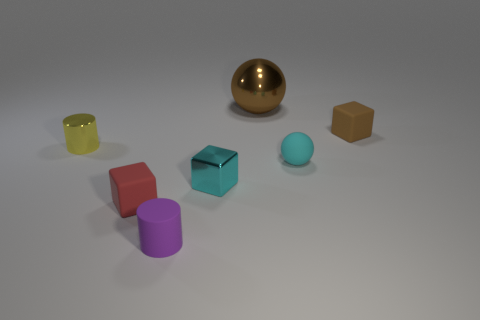Add 3 tiny metallic cubes. How many objects exist? 10 Subtract all balls. How many objects are left? 5 Subtract all small cyan matte objects. Subtract all small yellow cylinders. How many objects are left? 5 Add 6 small yellow metal cylinders. How many small yellow metal cylinders are left? 7 Add 3 matte cylinders. How many matte cylinders exist? 4 Subtract 1 yellow cylinders. How many objects are left? 6 